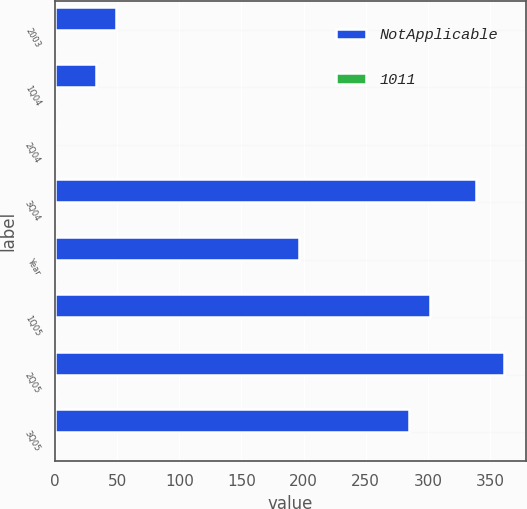<chart> <loc_0><loc_0><loc_500><loc_500><stacked_bar_chart><ecel><fcel>2003<fcel>1Q04<fcel>2Q04<fcel>3Q04<fcel>Year<fcel>1Q05<fcel>2Q05<fcel>3Q05<nl><fcel>NotApplicable<fcel>49<fcel>33<fcel>0.12<fcel>339<fcel>196<fcel>302<fcel>361<fcel>285<nl><fcel>1011<fcel>0.02<fcel>0.01<fcel>0.12<fcel>0.08<fcel>0.05<fcel>0.07<fcel>0.09<fcel>0.07<nl></chart> 